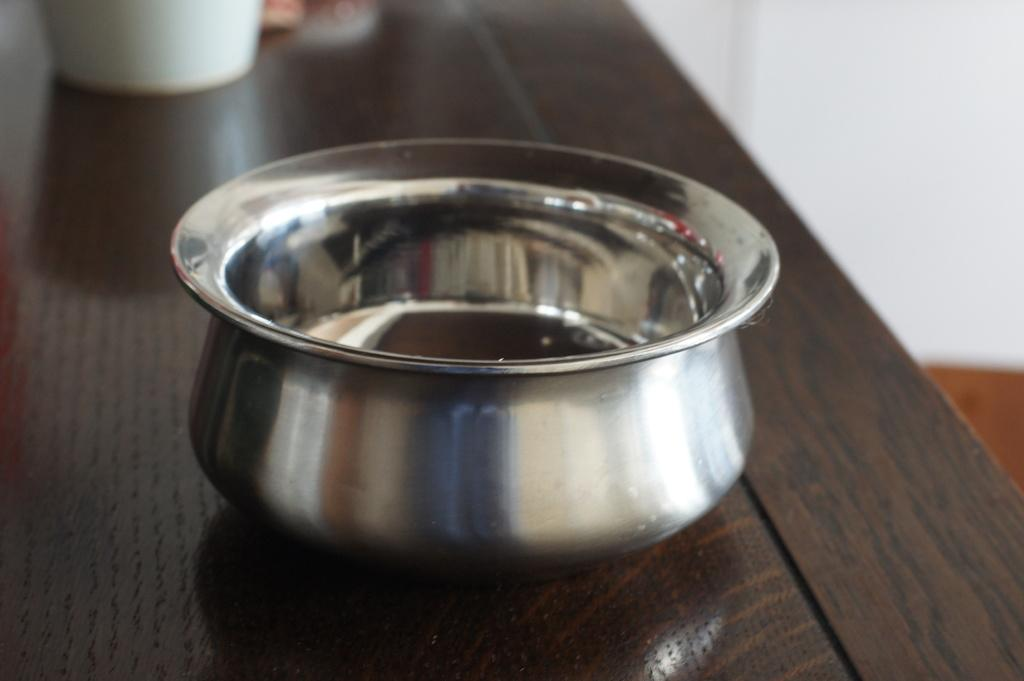What type of bowl is visible in the image? There is a steel bowl in the image. On what surface is the steel bowl placed? The steel bowl is placed on a brown table. What type of agreement was reached regarding the bowl in the image? There is no indication of any agreement in the image; it simply shows a steel bowl placed on a brown table. What type of waste is visible in the image? There is no waste visible in the image; it only shows a steel bowl placed on a brown table. 